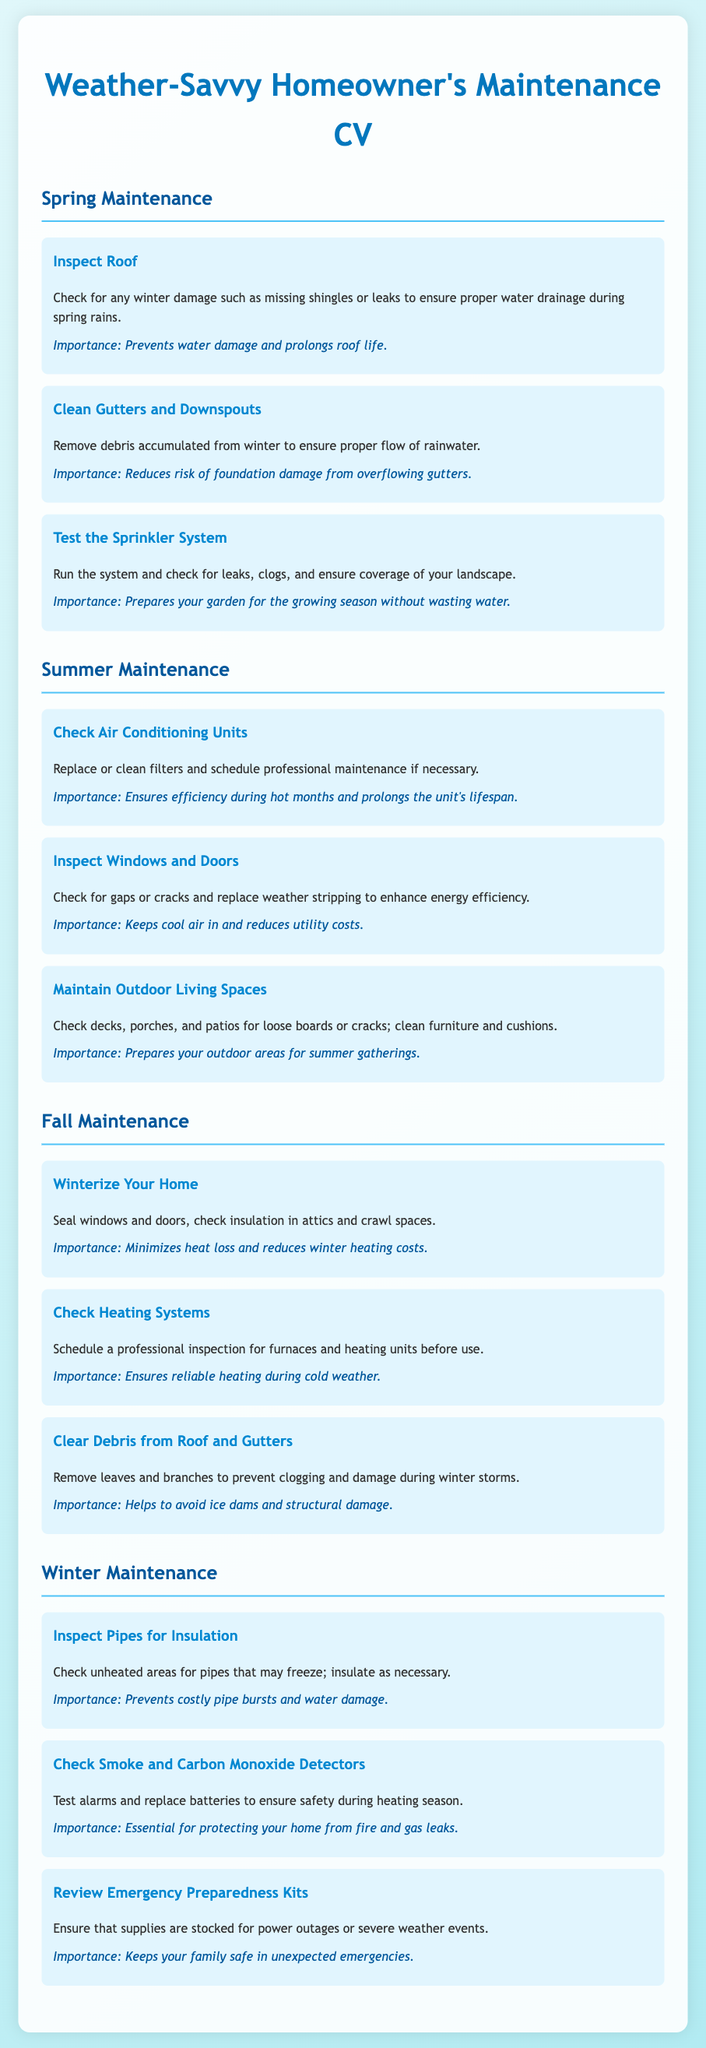What is the first task listed in Spring Maintenance? The first task is "Inspect Roof," and it involves checking for winter damage to ensure proper water drainage.
Answer: Inspect Roof How many tasks are listed under Summer Maintenance? There are three tasks listed under Summer Maintenance: Checking Air Conditioning Units, Inspecting Windows and Doors, and Maintaining Outdoor Living Spaces.
Answer: 3 What is the importance of clearing debris from roof and gutters in Fall Maintenance? The importance of this task is to prevent clogging and damage during winter storms.
Answer: Helps to avoid ice dams and structural damage What should be done to pipes in Winter Maintenance? Pipes in unheated areas should be checked for insulation; they may need insulation to prevent freezing.
Answer: Inspect Pipes for Insulation Which season requires reviewing emergency preparedness kits? Reviewing emergency preparedness kits is specified under Winter Maintenance.
Answer: Winter What is the last task listed under Fall Maintenance? The last task is "Clear Debris from Roof and Gutters."
Answer: Clear Debris from Roof and Gutters How often should smoke and carbon monoxide detectors be checked? The document does not specify frequency but emphasizes that smoke and carbon monoxide detectors should be tested in winter.
Answer: During heating season What action is suggested for air conditioning units during Summer Maintenance? It is suggested to replace or clean filters and schedule professional maintenance if necessary.
Answer: Replace or clean filters How many seasons are covered in the document? The document covers four seasons: Spring, Summer, Fall, and Winter.
Answer: 4 